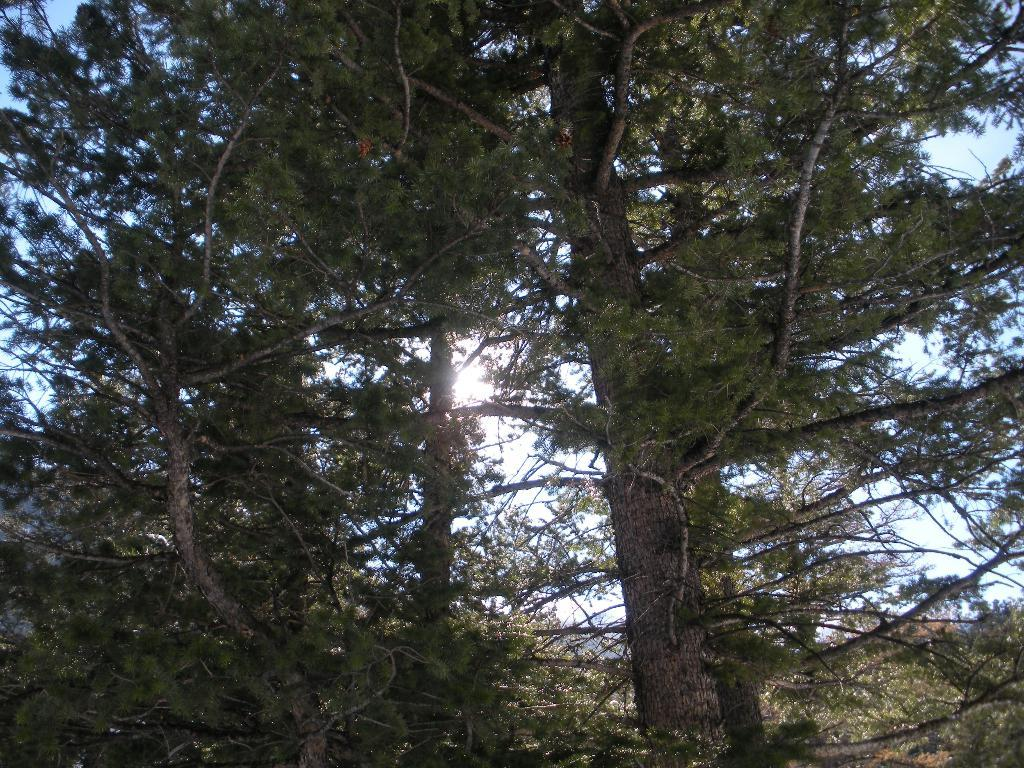What type of vegetation can be seen in the image? There are trees in the image. What part of the natural environment is visible in the image? The sky is visible in the background of the image. What type of loaf is being used to fight in the battle depicted in the image? There is no battle or loaf present in the image; it features trees and the sky. 